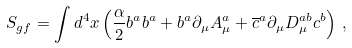<formula> <loc_0><loc_0><loc_500><loc_500>S _ { g f } = \int d ^ { 4 } x \left ( \frac { \alpha } { 2 } b ^ { a } b ^ { a } + b ^ { a } \partial _ { \mu } A _ { \mu } ^ { a } + \overline { c } ^ { a } \partial _ { \mu } D _ { \mu } ^ { a b } c ^ { b } \right ) \, ,</formula> 